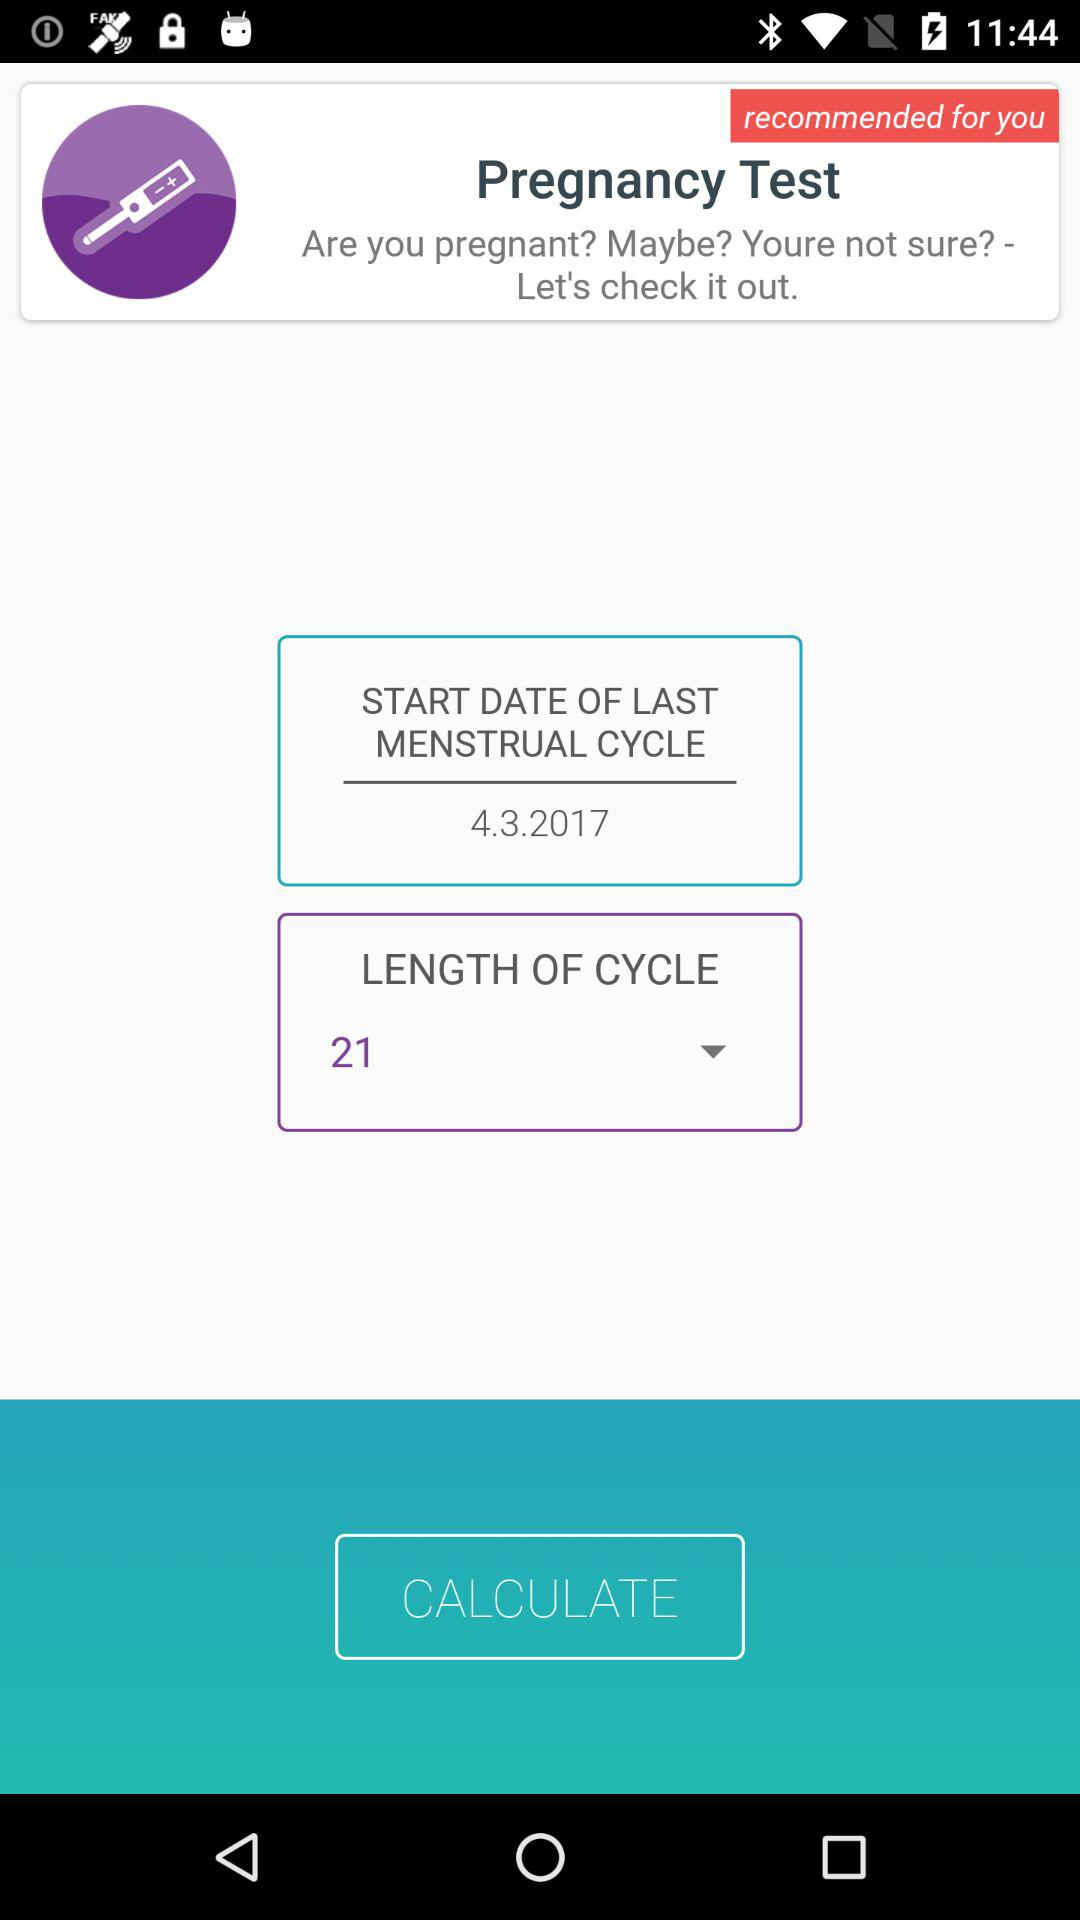What is the start date of the last menstrual cycle? The start date of the last menstrual cycle is April 3, 2017. 